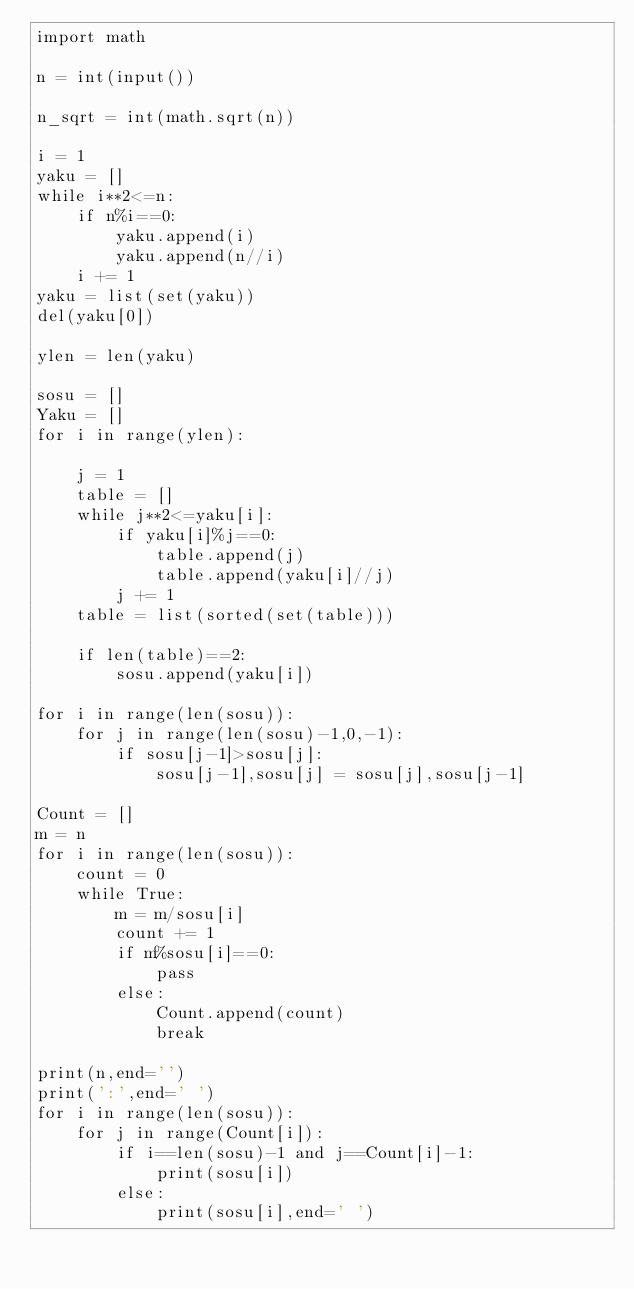<code> <loc_0><loc_0><loc_500><loc_500><_Python_>import math

n = int(input())

n_sqrt = int(math.sqrt(n))

i = 1
yaku = []
while i**2<=n:
    if n%i==0:
        yaku.append(i)
        yaku.append(n//i)
    i += 1
yaku = list(set(yaku))
del(yaku[0])

ylen = len(yaku)

sosu = []
Yaku = []
for i in range(ylen):
    
    j = 1
    table = []
    while j**2<=yaku[i]:
        if yaku[i]%j==0:
            table.append(j)
            table.append(yaku[i]//j)
        j += 1
    table = list(sorted(set(table)))
    
    if len(table)==2:
        sosu.append(yaku[i])

for i in range(len(sosu)):
    for j in range(len(sosu)-1,0,-1):
        if sosu[j-1]>sosu[j]:
            sosu[j-1],sosu[j] = sosu[j],sosu[j-1]

Count = []
m = n
for i in range(len(sosu)):
    count = 0
    while True:
        m = m/sosu[i]
        count += 1
        if m%sosu[i]==0:
            pass
        else:
            Count.append(count)
            break

print(n,end='')
print(':',end=' ')
for i in range(len(sosu)):
    for j in range(Count[i]):
        if i==len(sosu)-1 and j==Count[i]-1:
            print(sosu[i])
        else:
            print(sosu[i],end=' ')
</code> 